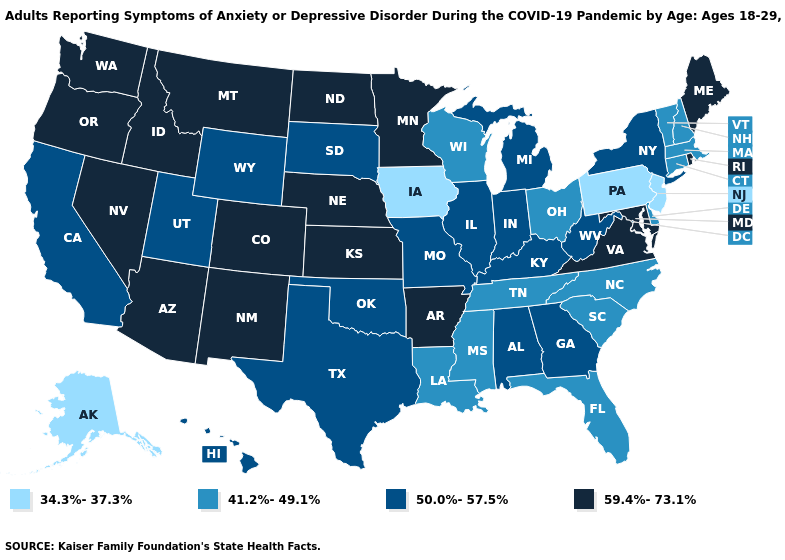Name the states that have a value in the range 50.0%-57.5%?
Short answer required. Alabama, California, Georgia, Hawaii, Illinois, Indiana, Kentucky, Michigan, Missouri, New York, Oklahoma, South Dakota, Texas, Utah, West Virginia, Wyoming. What is the value of North Dakota?
Be succinct. 59.4%-73.1%. Does New Jersey have a lower value than Iowa?
Be succinct. No. What is the value of Missouri?
Keep it brief. 50.0%-57.5%. Among the states that border North Carolina , which have the highest value?
Answer briefly. Virginia. Name the states that have a value in the range 59.4%-73.1%?
Keep it brief. Arizona, Arkansas, Colorado, Idaho, Kansas, Maine, Maryland, Minnesota, Montana, Nebraska, Nevada, New Mexico, North Dakota, Oregon, Rhode Island, Virginia, Washington. Does Connecticut have a higher value than Ohio?
Quick response, please. No. What is the value of Florida?
Keep it brief. 41.2%-49.1%. Name the states that have a value in the range 50.0%-57.5%?
Concise answer only. Alabama, California, Georgia, Hawaii, Illinois, Indiana, Kentucky, Michigan, Missouri, New York, Oklahoma, South Dakota, Texas, Utah, West Virginia, Wyoming. Does New Hampshire have the same value as Nevada?
Short answer required. No. Name the states that have a value in the range 59.4%-73.1%?
Answer briefly. Arizona, Arkansas, Colorado, Idaho, Kansas, Maine, Maryland, Minnesota, Montana, Nebraska, Nevada, New Mexico, North Dakota, Oregon, Rhode Island, Virginia, Washington. Among the states that border Wyoming , does Colorado have the lowest value?
Give a very brief answer. No. What is the value of Mississippi?
Give a very brief answer. 41.2%-49.1%. Which states have the highest value in the USA?
Quick response, please. Arizona, Arkansas, Colorado, Idaho, Kansas, Maine, Maryland, Minnesota, Montana, Nebraska, Nevada, New Mexico, North Dakota, Oregon, Rhode Island, Virginia, Washington. How many symbols are there in the legend?
Give a very brief answer. 4. 